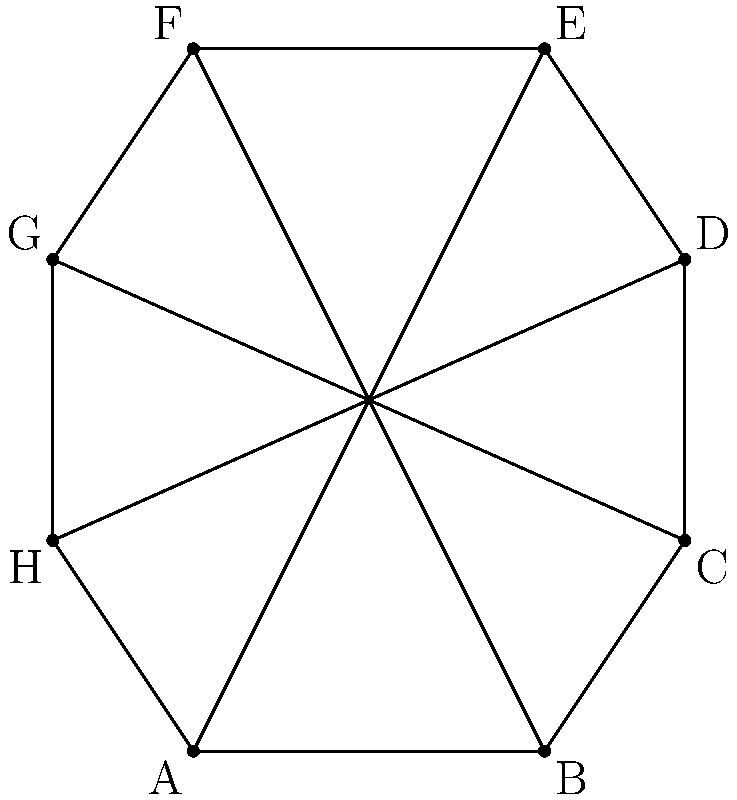During your visit to Beverley's St. Mary's Church, you notice its octagonal floor plan. If the interior angles of the octagon are all equal, what is the measure of each interior angle? To find the measure of each interior angle in a regular octagon, we can follow these steps:

1. Recall the formula for the sum of interior angles of a polygon with $n$ sides:
   $S = (n-2) \times 180°$

2. For an octagon, $n = 8$, so we substitute this into the formula:
   $S = (8-2) \times 180° = 6 \times 180° = 1080°$

3. Since all interior angles in a regular octagon are equal, we can divide the sum by 8 to find the measure of each angle:
   $\text{Each angle} = \frac{1080°}{8} = 135°$

4. We can verify this result using the fact that the sum of angles around a point is 360°:
   In the octagon, there are 8 triangles formed by drawing lines from the center to each vertex.
   Each of these triangles has one of the octagon's interior angles and two equal angles at the center.
   If we call the angle at the center $x$, then:
   $2x + 135° = 180°$ (sum of angles in a triangle)
   $2x = 45°$
   $x = 22.5°$

   Indeed, $22.5° \times 8 = 180°$, confirming our result.

Therefore, each interior angle of the regular octagonal floor plan measures 135°.
Answer: 135° 